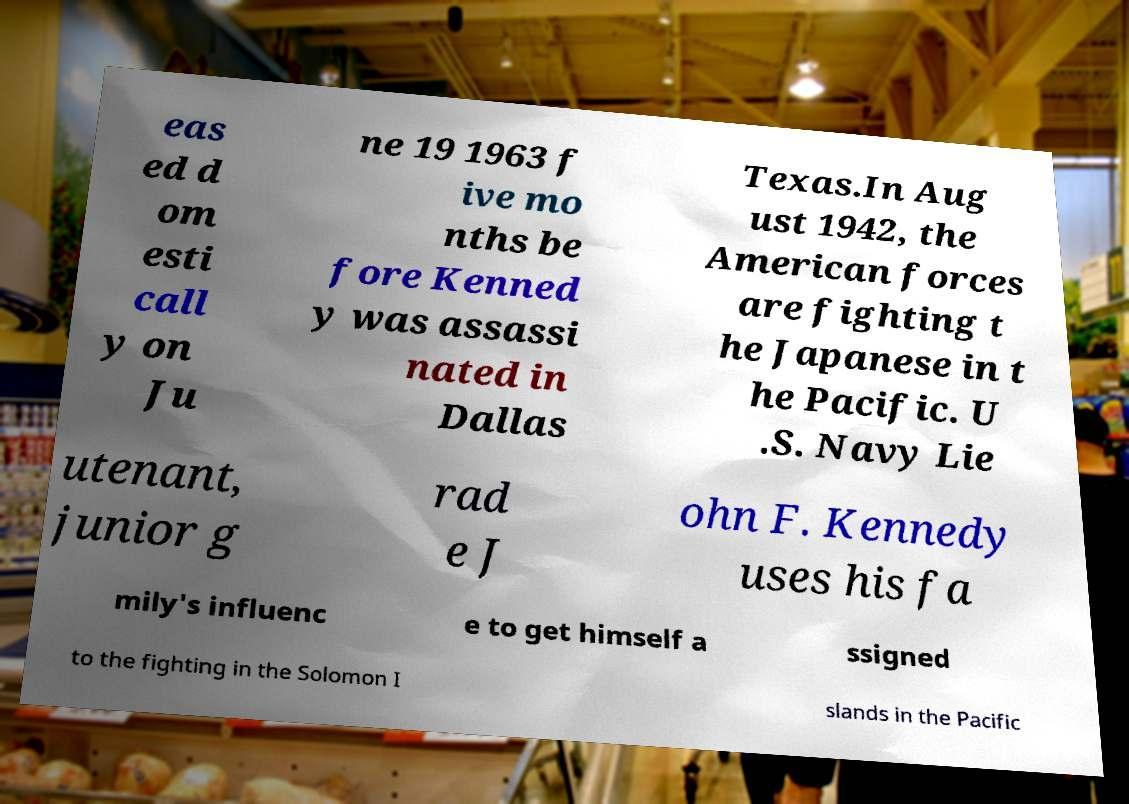Please read and relay the text visible in this image. What does it say? eas ed d om esti call y on Ju ne 19 1963 f ive mo nths be fore Kenned y was assassi nated in Dallas Texas.In Aug ust 1942, the American forces are fighting t he Japanese in t he Pacific. U .S. Navy Lie utenant, junior g rad e J ohn F. Kennedy uses his fa mily's influenc e to get himself a ssigned to the fighting in the Solomon I slands in the Pacific 